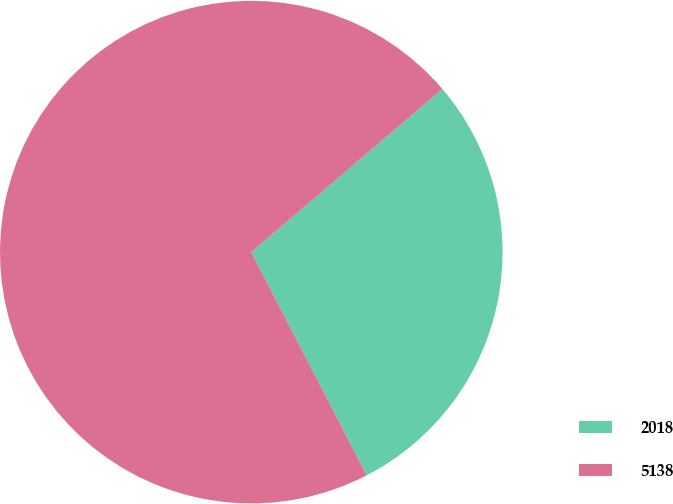Convert chart to OTSL. <chart><loc_0><loc_0><loc_500><loc_500><pie_chart><fcel>2018<fcel>5138<nl><fcel>28.65%<fcel>71.35%<nl></chart> 